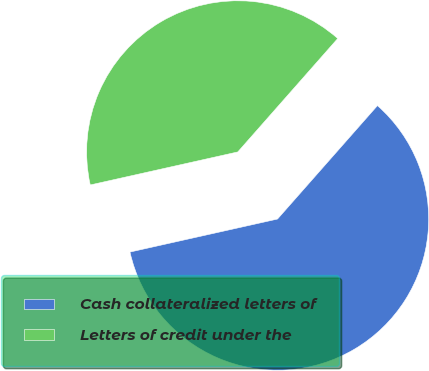<chart> <loc_0><loc_0><loc_500><loc_500><pie_chart><fcel>Cash collateralized letters of<fcel>Letters of credit under the<nl><fcel>60.0%<fcel>40.0%<nl></chart> 